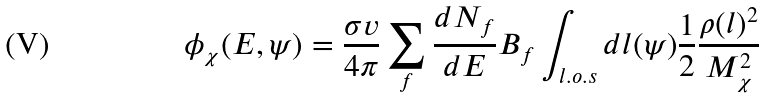Convert formula to latex. <formula><loc_0><loc_0><loc_500><loc_500>\phi _ { \chi } ( E , \psi ) = \frac { \sigma v } { 4 \pi } \sum _ { f } \frac { d N _ { f } } { d E } B _ { f } \int _ { l . o . s } d l ( \psi ) \frac { 1 } { 2 } \frac { \rho ( l ) ^ { 2 } } { M _ { \chi } ^ { 2 } }</formula> 